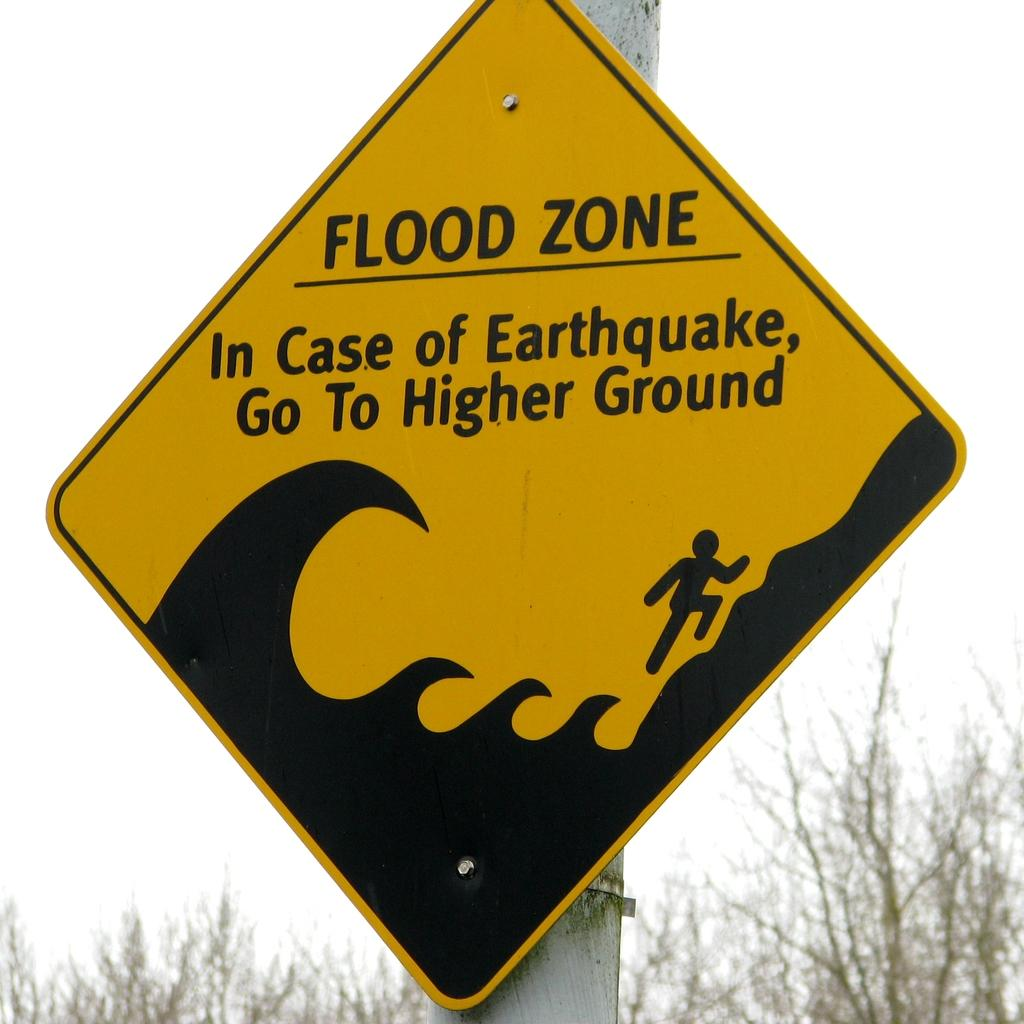Provide a one-sentence caption for the provided image. a yellow and black street sign warning of a flood zone. 